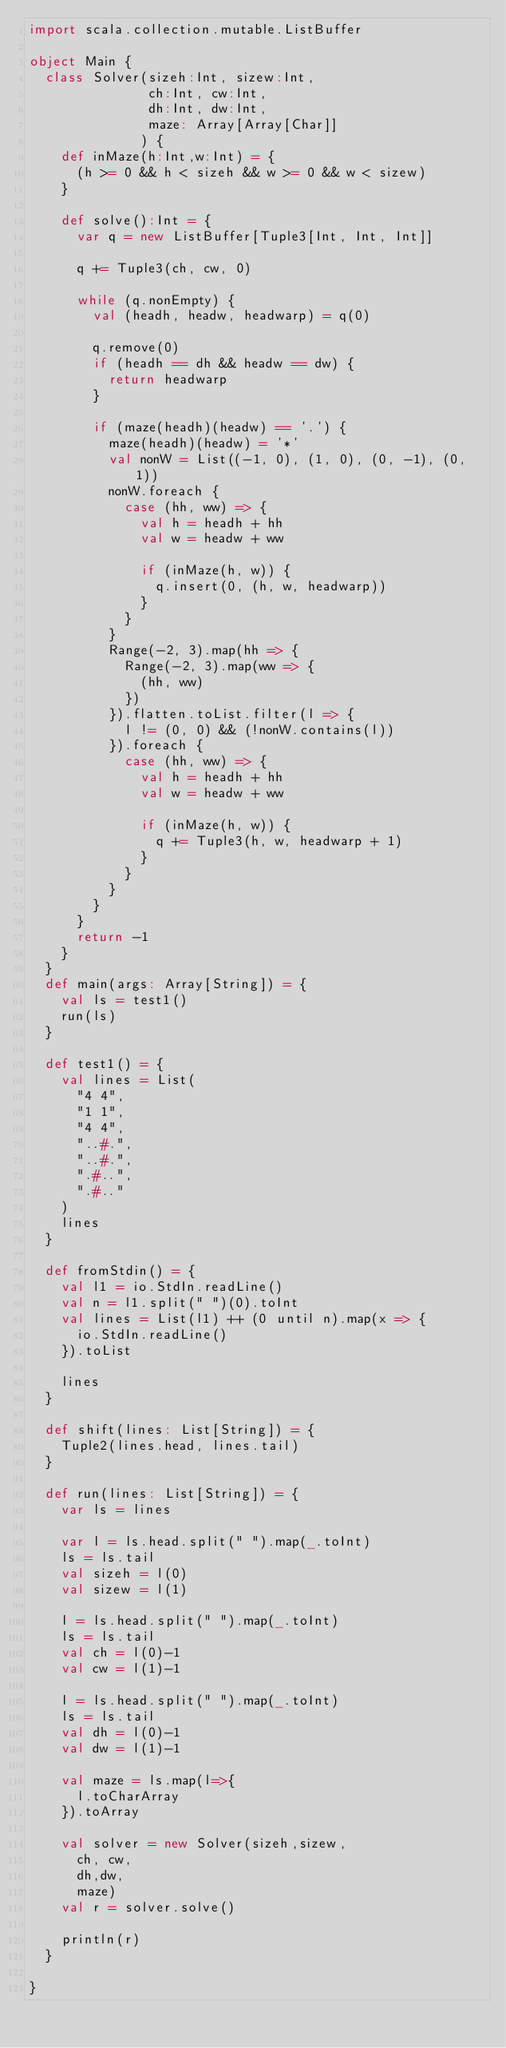<code> <loc_0><loc_0><loc_500><loc_500><_Scala_>import scala.collection.mutable.ListBuffer

object Main {
  class Solver(sizeh:Int, sizew:Int,
               ch:Int, cw:Int,
               dh:Int, dw:Int,
               maze: Array[Array[Char]]
              ) {
    def inMaze(h:Int,w:Int) = {
      (h >= 0 && h < sizeh && w >= 0 && w < sizew)
    }

    def solve():Int = {
      var q = new ListBuffer[Tuple3[Int, Int, Int]]

      q += Tuple3(ch, cw, 0)

      while (q.nonEmpty) {
        val (headh, headw, headwarp) = q(0)

        q.remove(0)
        if (headh == dh && headw == dw) {
          return headwarp
        }

        if (maze(headh)(headw) == '.') {
          maze(headh)(headw) = '*'
          val nonW = List((-1, 0), (1, 0), (0, -1), (0, 1))
          nonW.foreach {
            case (hh, ww) => {
              val h = headh + hh
              val w = headw + ww

              if (inMaze(h, w)) {
                q.insert(0, (h, w, headwarp))
              }
            }
          }
          Range(-2, 3).map(hh => {
            Range(-2, 3).map(ww => {
              (hh, ww)
            })
          }).flatten.toList.filter(l => {
            l != (0, 0) && (!nonW.contains(l))
          }).foreach {
            case (hh, ww) => {
              val h = headh + hh
              val w = headw + ww

              if (inMaze(h, w)) {
                q += Tuple3(h, w, headwarp + 1)
              }
            }
          }
        }
      }
      return -1
    }
  }
  def main(args: Array[String]) = {
    val ls = test1()
    run(ls)
  }

  def test1() = {
    val lines = List(
      "4 4",
      "1 1",
      "4 4",
      "..#.",
      "..#.",
      ".#..",
      ".#.."
    )
    lines
  }

  def fromStdin() = {
    val l1 = io.StdIn.readLine()
    val n = l1.split(" ")(0).toInt
    val lines = List(l1) ++ (0 until n).map(x => {
      io.StdIn.readLine()
    }).toList

    lines
  }

  def shift(lines: List[String]) = {
    Tuple2(lines.head, lines.tail)
  }

  def run(lines: List[String]) = {
    var ls = lines

    var l = ls.head.split(" ").map(_.toInt)
    ls = ls.tail
    val sizeh = l(0)
    val sizew = l(1)

    l = ls.head.split(" ").map(_.toInt)
    ls = ls.tail
    val ch = l(0)-1
    val cw = l(1)-1

    l = ls.head.split(" ").map(_.toInt)
    ls = ls.tail
    val dh = l(0)-1
    val dw = l(1)-1

    val maze = ls.map(l=>{
      l.toCharArray
    }).toArray

    val solver = new Solver(sizeh,sizew,
      ch, cw,
      dh,dw,
      maze)
    val r = solver.solve()

    println(r)
  }

}
</code> 